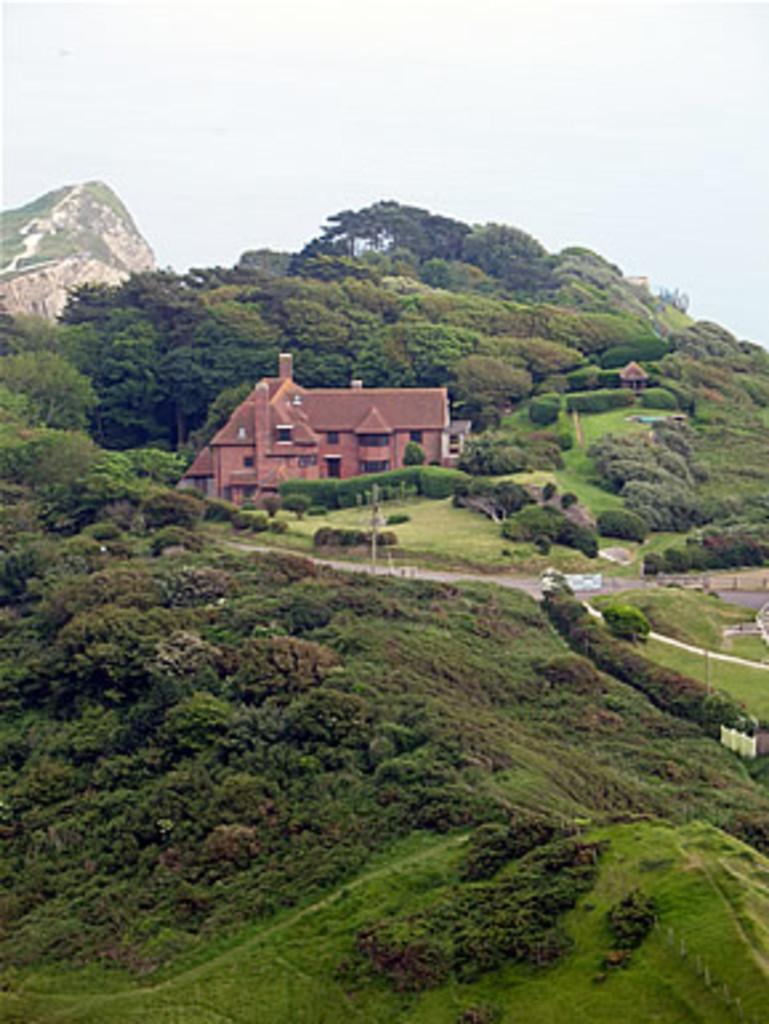Please provide a concise description of this image. Here we can see a house, grass, plants, trees, and a mountain. In the background there is sky. 